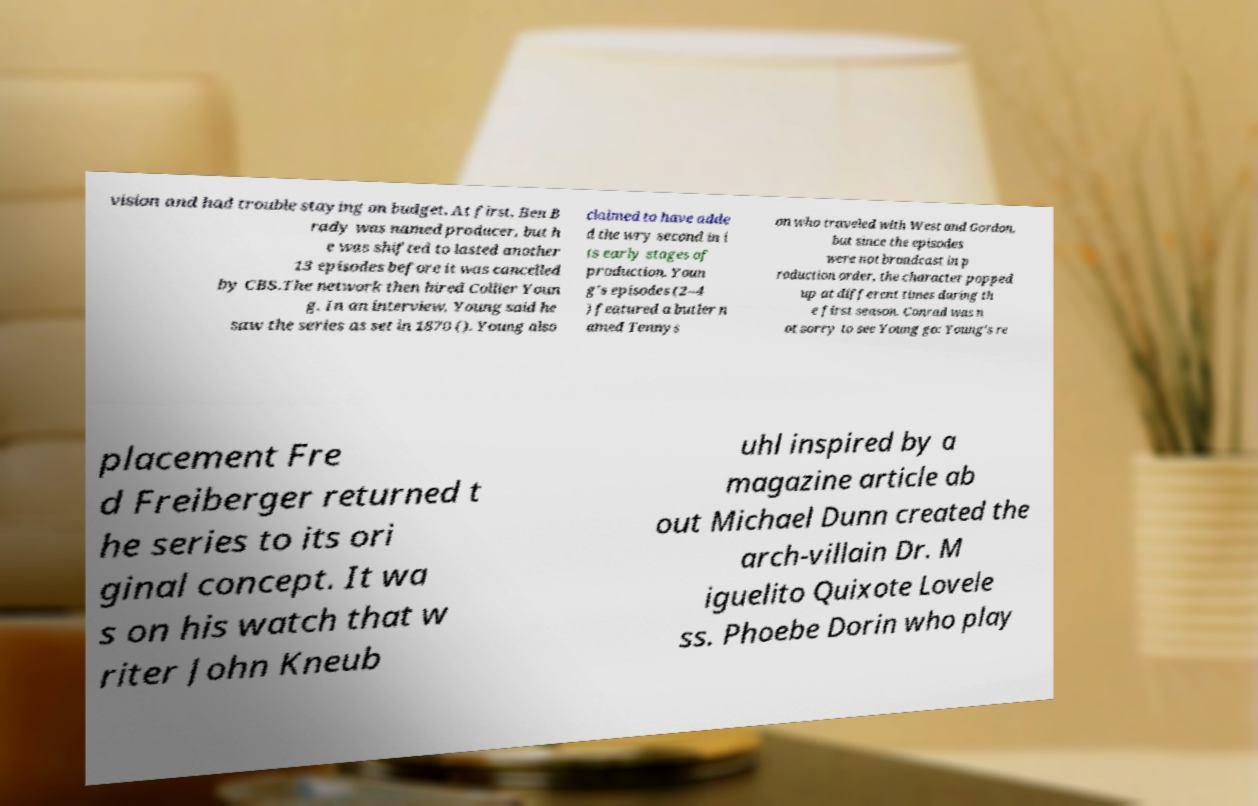Could you assist in decoding the text presented in this image and type it out clearly? vision and had trouble staying on budget. At first, Ben B rady was named producer, but h e was shifted to lasted another 13 episodes before it was cancelled by CBS.The network then hired Collier Youn g. In an interview, Young said he saw the series as set in 1870 (). Young also claimed to have adde d the wry second in i ts early stages of production. Youn g's episodes (2–4 ) featured a butler n amed Tennys on who traveled with West and Gordon, but since the episodes were not broadcast in p roduction order, the character popped up at different times during th e first season. Conrad was n ot sorry to see Young go: Young's re placement Fre d Freiberger returned t he series to its ori ginal concept. It wa s on his watch that w riter John Kneub uhl inspired by a magazine article ab out Michael Dunn created the arch-villain Dr. M iguelito Quixote Lovele ss. Phoebe Dorin who play 